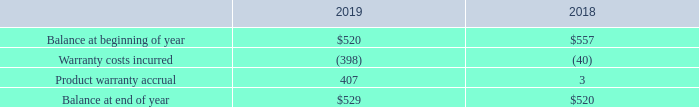15. Product Warranties
The Company generally provides its customers with a one-year warranty regarding the manufactured quality and functionality of its products. For some limited products, the warranty period has been extended. The Company establishes warranty reserves based on its product history, current information on repair costs and annual sales levels. As of April 30, 2019, and 2018, respectively, changes in the carrying amount of accrued product warranty costs, reported in accrued expenses on the consolidated balance sheet, were as follows (in thousands):
What is the beginning balance in 2019 and 2018 respectively?
Answer scale should be: thousand. $520, $557. What is the ending balance in 2019 and 2018 respectively?
Answer scale should be: thousand. $529, $520. How does the company establish warranty reserves? Based on its product history, current information on repair costs and annual sales levels. What is the change in beginning balance between 2018 and 2019?
Answer scale should be: thousand. 520-557
Answer: -37. What is the total warranty costs incurred in 2018 and 2019 altogether?
Answer scale should be: thousand. 398+40
Answer: 438. Which year has a higher ending balance? Look at Row 5 , and compare the values of COL3 and COL4 to derive the answer
Answer: 2019. 